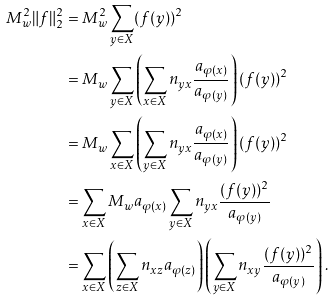<formula> <loc_0><loc_0><loc_500><loc_500>M _ { w } ^ { 2 } \| f \| _ { 2 } ^ { 2 } & = M _ { w } ^ { 2 } \sum _ { y \in X } ( f ( y ) ) ^ { 2 } \\ & = M _ { w } \sum _ { y \in X } \left ( \sum _ { x \in X } n _ { y x } \frac { a _ { \varphi ( x ) } } { a _ { \varphi ( y ) } } \right ) ( f ( y ) ) ^ { 2 } \\ & = M _ { w } \sum _ { x \in X } \left ( \sum _ { y \in X } n _ { y x } \frac { a _ { \varphi ( x ) } } { a _ { \varphi ( y ) } } \right ) ( f ( y ) ) ^ { 2 } \\ & = \sum _ { x \in X } M _ { w } a _ { \varphi ( x ) } \sum _ { y \in X } n _ { y x } \frac { ( f ( y ) ) ^ { 2 } } { a _ { \varphi ( y ) } } \\ & = \sum _ { x \in X } \left ( \sum _ { z \in X } n _ { x z } a _ { \varphi ( z ) } \right ) \left ( \sum _ { y \in X } n _ { x y } \frac { ( f ( y ) ) ^ { 2 } } { a _ { \varphi ( y ) } } \right ) .</formula> 